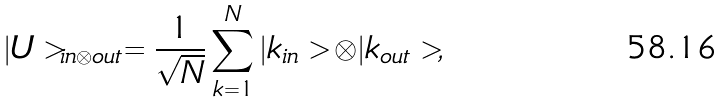<formula> <loc_0><loc_0><loc_500><loc_500>| U > _ { i n \otimes o u t } = \frac { 1 } { \sqrt { N } } \sum _ { k = 1 } ^ { N } | k _ { i n } > \otimes | k _ { o u t } > ,</formula> 